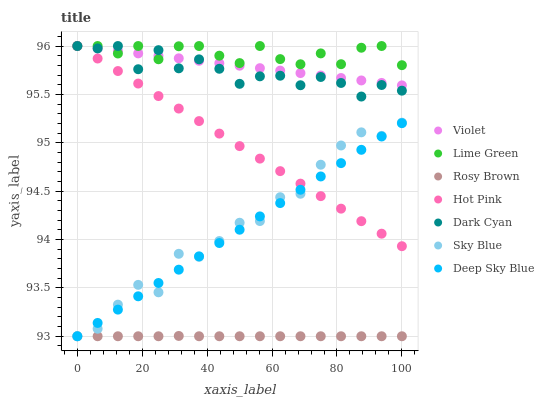Does Rosy Brown have the minimum area under the curve?
Answer yes or no. Yes. Does Lime Green have the maximum area under the curve?
Answer yes or no. Yes. Does Hot Pink have the minimum area under the curve?
Answer yes or no. No. Does Hot Pink have the maximum area under the curve?
Answer yes or no. No. Is Deep Sky Blue the smoothest?
Answer yes or no. Yes. Is Sky Blue the roughest?
Answer yes or no. Yes. Is Hot Pink the smoothest?
Answer yes or no. No. Is Hot Pink the roughest?
Answer yes or no. No. Does Rosy Brown have the lowest value?
Answer yes or no. Yes. Does Hot Pink have the lowest value?
Answer yes or no. No. Does Lime Green have the highest value?
Answer yes or no. Yes. Does Deep Sky Blue have the highest value?
Answer yes or no. No. Is Sky Blue less than Dark Cyan?
Answer yes or no. Yes. Is Dark Cyan greater than Deep Sky Blue?
Answer yes or no. Yes. Does Dark Cyan intersect Hot Pink?
Answer yes or no. Yes. Is Dark Cyan less than Hot Pink?
Answer yes or no. No. Is Dark Cyan greater than Hot Pink?
Answer yes or no. No. Does Sky Blue intersect Dark Cyan?
Answer yes or no. No. 